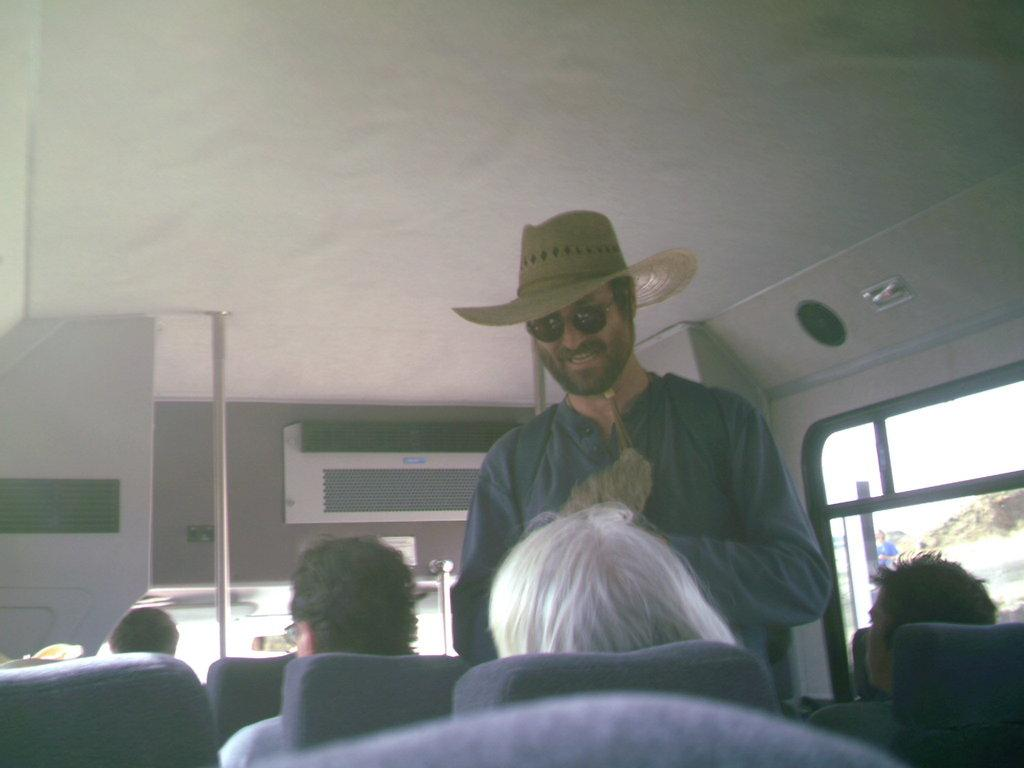What is the main subject of the image? There is a person standing in the image. Can you describe the person's attire? The person is wearing sunglasses and a hat. What are the other people in the image doing? There are people sitting on chairs in the image. Where are the chairs located? The chairs are in a bus. What feature of the bus is mentioned in the facts? There is a centralised air conditioning system in the bus. What type of example does the governor provide in the image? There is no governor present in the image, nor is there any indication of an example being provided. What type of vacation is the person in the image planning? There is no information about a vacation in the image or the facts provided. 